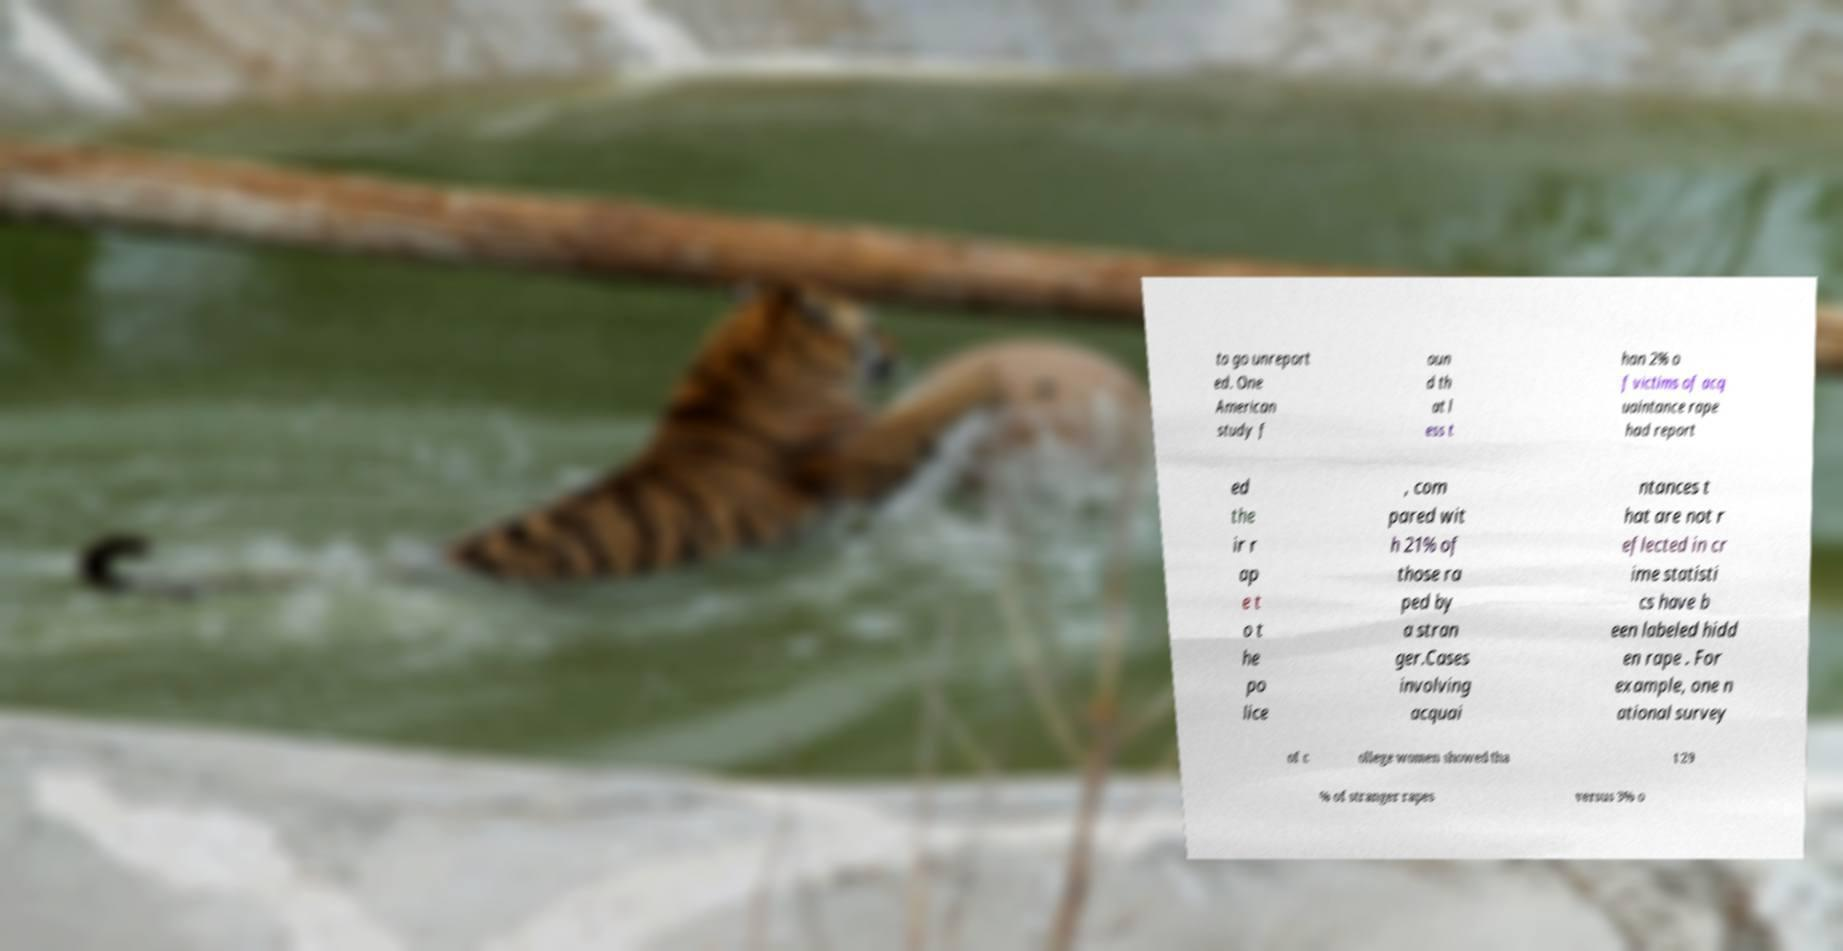Please identify and transcribe the text found in this image. to go unreport ed. One American study f oun d th at l ess t han 2% o f victims of acq uaintance rape had report ed the ir r ap e t o t he po lice , com pared wit h 21% of those ra ped by a stran ger.Cases involving acquai ntances t hat are not r eflected in cr ime statisti cs have b een labeled hidd en rape . For example, one n ational survey of c ollege women showed tha t 29 % of stranger rapes versus 3% o 